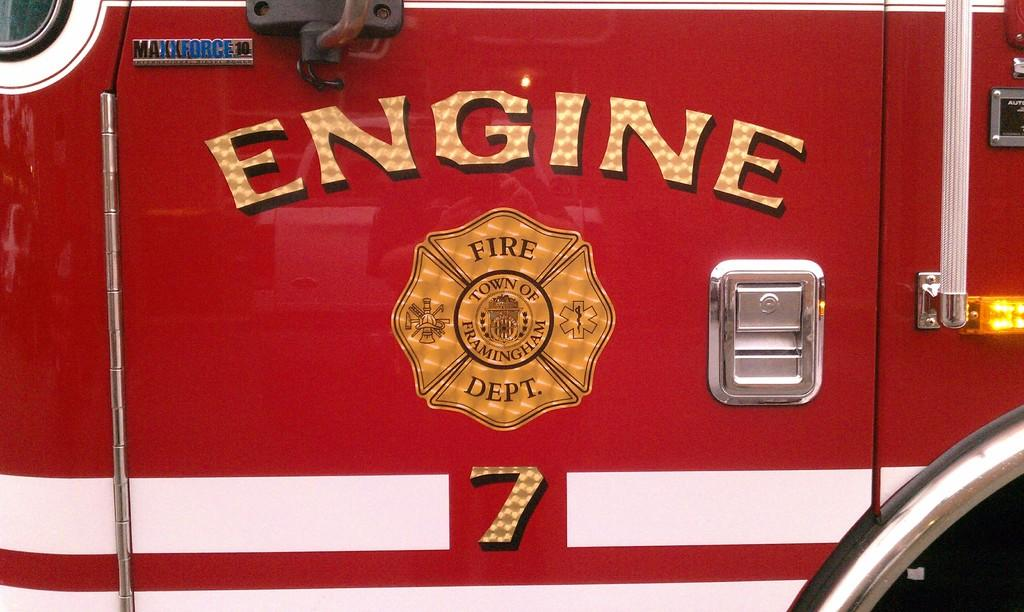What is the main subject of the image? The main subject of the image is a vehicle. What color is the vehicle? The vehicle is red in color. Are there any words or text on the vehicle? Yes, there is writing on the vehicle. What type of bread can be seen being discovered in the image? There is no bread or discovery present in the image; it features a red vehicle with writing on it. 